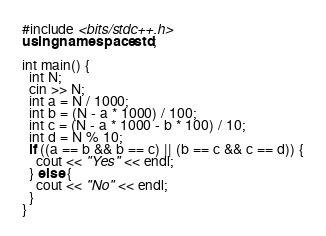Convert code to text. <code><loc_0><loc_0><loc_500><loc_500><_C++_>#include <bits/stdc++.h>
using namespace std;
 
int main() {
  int N;
  cin >> N;
  int a = N / 1000;
  int b = (N - a * 1000) / 100;
  int c = (N - a * 1000 - b * 100) / 10;
  int d = N % 10;
  if ((a == b && b == c) || (b == c && c == d)) {
    cout << "Yes" << endl;
  } else {
    cout << "No" << endl; 
  }
}</code> 